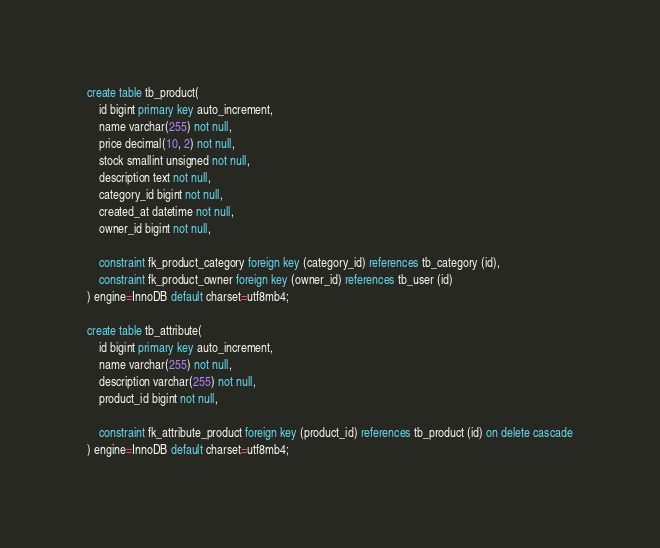<code> <loc_0><loc_0><loc_500><loc_500><_SQL_>create table tb_product(
    id bigint primary key auto_increment,
    name varchar(255) not null,
    price decimal(10, 2) not null,
    stock smallint unsigned not null,
    description text not null,
    category_id bigint not null,
    created_at datetime not null,
    owner_id bigint not null,

    constraint fk_product_category foreign key (category_id) references tb_category (id),
    constraint fk_product_owner foreign key (owner_id) references tb_user (id)
) engine=InnoDB default charset=utf8mb4;

create table tb_attribute(
    id bigint primary key auto_increment,
    name varchar(255) not null,
    description varchar(255) not null,
    product_id bigint not null,

    constraint fk_attribute_product foreign key (product_id) references tb_product (id) on delete cascade
) engine=InnoDB default charset=utf8mb4;</code> 